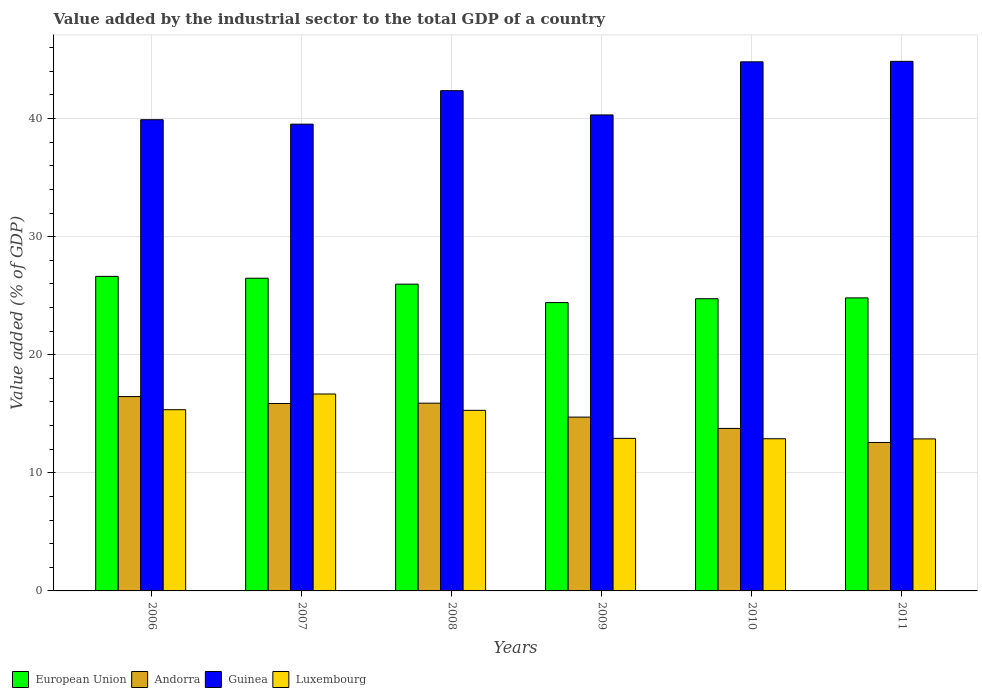How many different coloured bars are there?
Make the answer very short. 4. How many groups of bars are there?
Make the answer very short. 6. How many bars are there on the 2nd tick from the left?
Make the answer very short. 4. What is the label of the 2nd group of bars from the left?
Provide a succinct answer. 2007. What is the value added by the industrial sector to the total GDP in Guinea in 2007?
Offer a terse response. 39.52. Across all years, what is the maximum value added by the industrial sector to the total GDP in Guinea?
Keep it short and to the point. 44.84. Across all years, what is the minimum value added by the industrial sector to the total GDP in Andorra?
Your answer should be very brief. 12.57. In which year was the value added by the industrial sector to the total GDP in European Union maximum?
Offer a very short reply. 2006. What is the total value added by the industrial sector to the total GDP in Guinea in the graph?
Provide a short and direct response. 251.73. What is the difference between the value added by the industrial sector to the total GDP in European Union in 2006 and that in 2011?
Offer a very short reply. 1.82. What is the difference between the value added by the industrial sector to the total GDP in Luxembourg in 2008 and the value added by the industrial sector to the total GDP in European Union in 2010?
Offer a very short reply. -9.45. What is the average value added by the industrial sector to the total GDP in European Union per year?
Your answer should be very brief. 25.51. In the year 2006, what is the difference between the value added by the industrial sector to the total GDP in Luxembourg and value added by the industrial sector to the total GDP in European Union?
Ensure brevity in your answer.  -11.29. In how many years, is the value added by the industrial sector to the total GDP in Andorra greater than 6 %?
Provide a short and direct response. 6. What is the ratio of the value added by the industrial sector to the total GDP in Andorra in 2009 to that in 2010?
Keep it short and to the point. 1.07. What is the difference between the highest and the second highest value added by the industrial sector to the total GDP in Guinea?
Give a very brief answer. 0.04. What is the difference between the highest and the lowest value added by the industrial sector to the total GDP in European Union?
Your answer should be compact. 2.22. Is the sum of the value added by the industrial sector to the total GDP in Guinea in 2006 and 2010 greater than the maximum value added by the industrial sector to the total GDP in European Union across all years?
Keep it short and to the point. Yes. Is it the case that in every year, the sum of the value added by the industrial sector to the total GDP in Luxembourg and value added by the industrial sector to the total GDP in Guinea is greater than the sum of value added by the industrial sector to the total GDP in European Union and value added by the industrial sector to the total GDP in Andorra?
Ensure brevity in your answer.  Yes. What does the 3rd bar from the left in 2008 represents?
Your answer should be compact. Guinea. What does the 4th bar from the right in 2007 represents?
Provide a short and direct response. European Union. How many bars are there?
Offer a very short reply. 24. Are all the bars in the graph horizontal?
Ensure brevity in your answer.  No. How many years are there in the graph?
Give a very brief answer. 6. Does the graph contain any zero values?
Make the answer very short. No. How many legend labels are there?
Your answer should be compact. 4. What is the title of the graph?
Ensure brevity in your answer.  Value added by the industrial sector to the total GDP of a country. Does "San Marino" appear as one of the legend labels in the graph?
Offer a terse response. No. What is the label or title of the X-axis?
Your response must be concise. Years. What is the label or title of the Y-axis?
Give a very brief answer. Value added (% of GDP). What is the Value added (% of GDP) in European Union in 2006?
Give a very brief answer. 26.64. What is the Value added (% of GDP) in Andorra in 2006?
Give a very brief answer. 16.46. What is the Value added (% of GDP) in Guinea in 2006?
Your response must be concise. 39.9. What is the Value added (% of GDP) of Luxembourg in 2006?
Your answer should be compact. 15.34. What is the Value added (% of GDP) of European Union in 2007?
Ensure brevity in your answer.  26.48. What is the Value added (% of GDP) of Andorra in 2007?
Offer a very short reply. 15.87. What is the Value added (% of GDP) of Guinea in 2007?
Your answer should be compact. 39.52. What is the Value added (% of GDP) in Luxembourg in 2007?
Provide a succinct answer. 16.67. What is the Value added (% of GDP) in European Union in 2008?
Give a very brief answer. 25.98. What is the Value added (% of GDP) of Andorra in 2008?
Ensure brevity in your answer.  15.9. What is the Value added (% of GDP) in Guinea in 2008?
Ensure brevity in your answer.  42.36. What is the Value added (% of GDP) in Luxembourg in 2008?
Give a very brief answer. 15.29. What is the Value added (% of GDP) of European Union in 2009?
Ensure brevity in your answer.  24.41. What is the Value added (% of GDP) of Andorra in 2009?
Ensure brevity in your answer.  14.72. What is the Value added (% of GDP) of Guinea in 2009?
Your response must be concise. 40.31. What is the Value added (% of GDP) in Luxembourg in 2009?
Your answer should be compact. 12.92. What is the Value added (% of GDP) of European Union in 2010?
Provide a short and direct response. 24.74. What is the Value added (% of GDP) in Andorra in 2010?
Provide a short and direct response. 13.76. What is the Value added (% of GDP) of Guinea in 2010?
Make the answer very short. 44.8. What is the Value added (% of GDP) of Luxembourg in 2010?
Make the answer very short. 12.89. What is the Value added (% of GDP) in European Union in 2011?
Offer a terse response. 24.81. What is the Value added (% of GDP) of Andorra in 2011?
Provide a succinct answer. 12.57. What is the Value added (% of GDP) of Guinea in 2011?
Give a very brief answer. 44.84. What is the Value added (% of GDP) of Luxembourg in 2011?
Make the answer very short. 12.87. Across all years, what is the maximum Value added (% of GDP) of European Union?
Give a very brief answer. 26.64. Across all years, what is the maximum Value added (% of GDP) of Andorra?
Your answer should be compact. 16.46. Across all years, what is the maximum Value added (% of GDP) in Guinea?
Keep it short and to the point. 44.84. Across all years, what is the maximum Value added (% of GDP) of Luxembourg?
Provide a succinct answer. 16.67. Across all years, what is the minimum Value added (% of GDP) of European Union?
Provide a succinct answer. 24.41. Across all years, what is the minimum Value added (% of GDP) in Andorra?
Offer a very short reply. 12.57. Across all years, what is the minimum Value added (% of GDP) of Guinea?
Your answer should be very brief. 39.52. Across all years, what is the minimum Value added (% of GDP) in Luxembourg?
Make the answer very short. 12.87. What is the total Value added (% of GDP) in European Union in the graph?
Offer a terse response. 153.06. What is the total Value added (% of GDP) of Andorra in the graph?
Ensure brevity in your answer.  89.27. What is the total Value added (% of GDP) in Guinea in the graph?
Offer a terse response. 251.73. What is the total Value added (% of GDP) of Luxembourg in the graph?
Your answer should be compact. 85.99. What is the difference between the Value added (% of GDP) in European Union in 2006 and that in 2007?
Ensure brevity in your answer.  0.16. What is the difference between the Value added (% of GDP) in Andorra in 2006 and that in 2007?
Ensure brevity in your answer.  0.59. What is the difference between the Value added (% of GDP) in Guinea in 2006 and that in 2007?
Provide a short and direct response. 0.38. What is the difference between the Value added (% of GDP) of Luxembourg in 2006 and that in 2007?
Your answer should be compact. -1.33. What is the difference between the Value added (% of GDP) of European Union in 2006 and that in 2008?
Offer a very short reply. 0.66. What is the difference between the Value added (% of GDP) in Andorra in 2006 and that in 2008?
Your answer should be very brief. 0.56. What is the difference between the Value added (% of GDP) of Guinea in 2006 and that in 2008?
Your answer should be compact. -2.46. What is the difference between the Value added (% of GDP) of Luxembourg in 2006 and that in 2008?
Provide a succinct answer. 0.05. What is the difference between the Value added (% of GDP) of European Union in 2006 and that in 2009?
Your response must be concise. 2.22. What is the difference between the Value added (% of GDP) of Andorra in 2006 and that in 2009?
Ensure brevity in your answer.  1.74. What is the difference between the Value added (% of GDP) of Guinea in 2006 and that in 2009?
Keep it short and to the point. -0.41. What is the difference between the Value added (% of GDP) in Luxembourg in 2006 and that in 2009?
Your answer should be very brief. 2.43. What is the difference between the Value added (% of GDP) in European Union in 2006 and that in 2010?
Your answer should be very brief. 1.89. What is the difference between the Value added (% of GDP) in Andorra in 2006 and that in 2010?
Offer a very short reply. 2.7. What is the difference between the Value added (% of GDP) in Guinea in 2006 and that in 2010?
Your response must be concise. -4.9. What is the difference between the Value added (% of GDP) in Luxembourg in 2006 and that in 2010?
Provide a succinct answer. 2.46. What is the difference between the Value added (% of GDP) of European Union in 2006 and that in 2011?
Offer a very short reply. 1.82. What is the difference between the Value added (% of GDP) in Andorra in 2006 and that in 2011?
Make the answer very short. 3.89. What is the difference between the Value added (% of GDP) of Guinea in 2006 and that in 2011?
Ensure brevity in your answer.  -4.94. What is the difference between the Value added (% of GDP) of Luxembourg in 2006 and that in 2011?
Your response must be concise. 2.47. What is the difference between the Value added (% of GDP) of European Union in 2007 and that in 2008?
Offer a very short reply. 0.5. What is the difference between the Value added (% of GDP) of Andorra in 2007 and that in 2008?
Offer a terse response. -0.03. What is the difference between the Value added (% of GDP) of Guinea in 2007 and that in 2008?
Offer a very short reply. -2.84. What is the difference between the Value added (% of GDP) of Luxembourg in 2007 and that in 2008?
Your answer should be compact. 1.38. What is the difference between the Value added (% of GDP) in European Union in 2007 and that in 2009?
Give a very brief answer. 2.06. What is the difference between the Value added (% of GDP) of Andorra in 2007 and that in 2009?
Offer a very short reply. 1.15. What is the difference between the Value added (% of GDP) of Guinea in 2007 and that in 2009?
Provide a succinct answer. -0.78. What is the difference between the Value added (% of GDP) of Luxembourg in 2007 and that in 2009?
Keep it short and to the point. 3.76. What is the difference between the Value added (% of GDP) in European Union in 2007 and that in 2010?
Your answer should be very brief. 1.74. What is the difference between the Value added (% of GDP) in Andorra in 2007 and that in 2010?
Your response must be concise. 2.11. What is the difference between the Value added (% of GDP) in Guinea in 2007 and that in 2010?
Provide a short and direct response. -5.28. What is the difference between the Value added (% of GDP) in Luxembourg in 2007 and that in 2010?
Offer a very short reply. 3.79. What is the difference between the Value added (% of GDP) in European Union in 2007 and that in 2011?
Your response must be concise. 1.67. What is the difference between the Value added (% of GDP) in Andorra in 2007 and that in 2011?
Your answer should be very brief. 3.3. What is the difference between the Value added (% of GDP) in Guinea in 2007 and that in 2011?
Your answer should be very brief. -5.32. What is the difference between the Value added (% of GDP) in Luxembourg in 2007 and that in 2011?
Make the answer very short. 3.8. What is the difference between the Value added (% of GDP) in European Union in 2008 and that in 2009?
Keep it short and to the point. 1.56. What is the difference between the Value added (% of GDP) in Andorra in 2008 and that in 2009?
Keep it short and to the point. 1.18. What is the difference between the Value added (% of GDP) in Guinea in 2008 and that in 2009?
Make the answer very short. 2.05. What is the difference between the Value added (% of GDP) of Luxembourg in 2008 and that in 2009?
Your response must be concise. 2.37. What is the difference between the Value added (% of GDP) in European Union in 2008 and that in 2010?
Your answer should be very brief. 1.23. What is the difference between the Value added (% of GDP) in Andorra in 2008 and that in 2010?
Give a very brief answer. 2.14. What is the difference between the Value added (% of GDP) of Guinea in 2008 and that in 2010?
Your answer should be very brief. -2.44. What is the difference between the Value added (% of GDP) in Luxembourg in 2008 and that in 2010?
Give a very brief answer. 2.41. What is the difference between the Value added (% of GDP) of European Union in 2008 and that in 2011?
Provide a succinct answer. 1.17. What is the difference between the Value added (% of GDP) in Andorra in 2008 and that in 2011?
Give a very brief answer. 3.33. What is the difference between the Value added (% of GDP) in Guinea in 2008 and that in 2011?
Offer a very short reply. -2.48. What is the difference between the Value added (% of GDP) of Luxembourg in 2008 and that in 2011?
Your answer should be compact. 2.42. What is the difference between the Value added (% of GDP) of European Union in 2009 and that in 2010?
Your response must be concise. -0.33. What is the difference between the Value added (% of GDP) of Andorra in 2009 and that in 2010?
Give a very brief answer. 0.96. What is the difference between the Value added (% of GDP) of Guinea in 2009 and that in 2010?
Offer a very short reply. -4.5. What is the difference between the Value added (% of GDP) in Luxembourg in 2009 and that in 2010?
Give a very brief answer. 0.03. What is the difference between the Value added (% of GDP) of European Union in 2009 and that in 2011?
Make the answer very short. -0.4. What is the difference between the Value added (% of GDP) in Andorra in 2009 and that in 2011?
Make the answer very short. 2.15. What is the difference between the Value added (% of GDP) in Guinea in 2009 and that in 2011?
Offer a very short reply. -4.54. What is the difference between the Value added (% of GDP) in Luxembourg in 2009 and that in 2011?
Keep it short and to the point. 0.04. What is the difference between the Value added (% of GDP) in European Union in 2010 and that in 2011?
Your answer should be compact. -0.07. What is the difference between the Value added (% of GDP) of Andorra in 2010 and that in 2011?
Provide a short and direct response. 1.19. What is the difference between the Value added (% of GDP) in Guinea in 2010 and that in 2011?
Provide a short and direct response. -0.04. What is the difference between the Value added (% of GDP) of Luxembourg in 2010 and that in 2011?
Provide a short and direct response. 0.01. What is the difference between the Value added (% of GDP) of European Union in 2006 and the Value added (% of GDP) of Andorra in 2007?
Your response must be concise. 10.76. What is the difference between the Value added (% of GDP) of European Union in 2006 and the Value added (% of GDP) of Guinea in 2007?
Keep it short and to the point. -12.89. What is the difference between the Value added (% of GDP) of European Union in 2006 and the Value added (% of GDP) of Luxembourg in 2007?
Offer a very short reply. 9.96. What is the difference between the Value added (% of GDP) of Andorra in 2006 and the Value added (% of GDP) of Guinea in 2007?
Keep it short and to the point. -23.07. What is the difference between the Value added (% of GDP) of Andorra in 2006 and the Value added (% of GDP) of Luxembourg in 2007?
Make the answer very short. -0.22. What is the difference between the Value added (% of GDP) of Guinea in 2006 and the Value added (% of GDP) of Luxembourg in 2007?
Your answer should be very brief. 23.23. What is the difference between the Value added (% of GDP) in European Union in 2006 and the Value added (% of GDP) in Andorra in 2008?
Ensure brevity in your answer.  10.74. What is the difference between the Value added (% of GDP) of European Union in 2006 and the Value added (% of GDP) of Guinea in 2008?
Offer a very short reply. -15.72. What is the difference between the Value added (% of GDP) in European Union in 2006 and the Value added (% of GDP) in Luxembourg in 2008?
Offer a very short reply. 11.34. What is the difference between the Value added (% of GDP) of Andorra in 2006 and the Value added (% of GDP) of Guinea in 2008?
Provide a succinct answer. -25.9. What is the difference between the Value added (% of GDP) of Andorra in 2006 and the Value added (% of GDP) of Luxembourg in 2008?
Give a very brief answer. 1.17. What is the difference between the Value added (% of GDP) in Guinea in 2006 and the Value added (% of GDP) in Luxembourg in 2008?
Your answer should be very brief. 24.61. What is the difference between the Value added (% of GDP) of European Union in 2006 and the Value added (% of GDP) of Andorra in 2009?
Your answer should be compact. 11.92. What is the difference between the Value added (% of GDP) of European Union in 2006 and the Value added (% of GDP) of Guinea in 2009?
Your answer should be very brief. -13.67. What is the difference between the Value added (% of GDP) of European Union in 2006 and the Value added (% of GDP) of Luxembourg in 2009?
Keep it short and to the point. 13.72. What is the difference between the Value added (% of GDP) in Andorra in 2006 and the Value added (% of GDP) in Guinea in 2009?
Offer a very short reply. -23.85. What is the difference between the Value added (% of GDP) of Andorra in 2006 and the Value added (% of GDP) of Luxembourg in 2009?
Give a very brief answer. 3.54. What is the difference between the Value added (% of GDP) of Guinea in 2006 and the Value added (% of GDP) of Luxembourg in 2009?
Your answer should be very brief. 26.98. What is the difference between the Value added (% of GDP) in European Union in 2006 and the Value added (% of GDP) in Andorra in 2010?
Ensure brevity in your answer.  12.88. What is the difference between the Value added (% of GDP) in European Union in 2006 and the Value added (% of GDP) in Guinea in 2010?
Provide a short and direct response. -18.17. What is the difference between the Value added (% of GDP) in European Union in 2006 and the Value added (% of GDP) in Luxembourg in 2010?
Make the answer very short. 13.75. What is the difference between the Value added (% of GDP) of Andorra in 2006 and the Value added (% of GDP) of Guinea in 2010?
Keep it short and to the point. -28.35. What is the difference between the Value added (% of GDP) in Andorra in 2006 and the Value added (% of GDP) in Luxembourg in 2010?
Offer a very short reply. 3.57. What is the difference between the Value added (% of GDP) in Guinea in 2006 and the Value added (% of GDP) in Luxembourg in 2010?
Your answer should be very brief. 27.01. What is the difference between the Value added (% of GDP) of European Union in 2006 and the Value added (% of GDP) of Andorra in 2011?
Ensure brevity in your answer.  14.07. What is the difference between the Value added (% of GDP) of European Union in 2006 and the Value added (% of GDP) of Guinea in 2011?
Your response must be concise. -18.21. What is the difference between the Value added (% of GDP) in European Union in 2006 and the Value added (% of GDP) in Luxembourg in 2011?
Ensure brevity in your answer.  13.76. What is the difference between the Value added (% of GDP) of Andorra in 2006 and the Value added (% of GDP) of Guinea in 2011?
Your response must be concise. -28.39. What is the difference between the Value added (% of GDP) of Andorra in 2006 and the Value added (% of GDP) of Luxembourg in 2011?
Your response must be concise. 3.58. What is the difference between the Value added (% of GDP) of Guinea in 2006 and the Value added (% of GDP) of Luxembourg in 2011?
Offer a very short reply. 27.03. What is the difference between the Value added (% of GDP) in European Union in 2007 and the Value added (% of GDP) in Andorra in 2008?
Provide a succinct answer. 10.58. What is the difference between the Value added (% of GDP) of European Union in 2007 and the Value added (% of GDP) of Guinea in 2008?
Offer a very short reply. -15.88. What is the difference between the Value added (% of GDP) in European Union in 2007 and the Value added (% of GDP) in Luxembourg in 2008?
Offer a terse response. 11.19. What is the difference between the Value added (% of GDP) in Andorra in 2007 and the Value added (% of GDP) in Guinea in 2008?
Your answer should be very brief. -26.49. What is the difference between the Value added (% of GDP) in Andorra in 2007 and the Value added (% of GDP) in Luxembourg in 2008?
Your response must be concise. 0.58. What is the difference between the Value added (% of GDP) in Guinea in 2007 and the Value added (% of GDP) in Luxembourg in 2008?
Give a very brief answer. 24.23. What is the difference between the Value added (% of GDP) of European Union in 2007 and the Value added (% of GDP) of Andorra in 2009?
Your response must be concise. 11.76. What is the difference between the Value added (% of GDP) of European Union in 2007 and the Value added (% of GDP) of Guinea in 2009?
Keep it short and to the point. -13.83. What is the difference between the Value added (% of GDP) of European Union in 2007 and the Value added (% of GDP) of Luxembourg in 2009?
Make the answer very short. 13.56. What is the difference between the Value added (% of GDP) of Andorra in 2007 and the Value added (% of GDP) of Guinea in 2009?
Offer a terse response. -24.43. What is the difference between the Value added (% of GDP) in Andorra in 2007 and the Value added (% of GDP) in Luxembourg in 2009?
Offer a terse response. 2.95. What is the difference between the Value added (% of GDP) of Guinea in 2007 and the Value added (% of GDP) of Luxembourg in 2009?
Provide a succinct answer. 26.61. What is the difference between the Value added (% of GDP) in European Union in 2007 and the Value added (% of GDP) in Andorra in 2010?
Offer a very short reply. 12.72. What is the difference between the Value added (% of GDP) in European Union in 2007 and the Value added (% of GDP) in Guinea in 2010?
Your response must be concise. -18.32. What is the difference between the Value added (% of GDP) in European Union in 2007 and the Value added (% of GDP) in Luxembourg in 2010?
Provide a short and direct response. 13.59. What is the difference between the Value added (% of GDP) of Andorra in 2007 and the Value added (% of GDP) of Guinea in 2010?
Provide a succinct answer. -28.93. What is the difference between the Value added (% of GDP) of Andorra in 2007 and the Value added (% of GDP) of Luxembourg in 2010?
Offer a very short reply. 2.99. What is the difference between the Value added (% of GDP) of Guinea in 2007 and the Value added (% of GDP) of Luxembourg in 2010?
Keep it short and to the point. 26.64. What is the difference between the Value added (% of GDP) in European Union in 2007 and the Value added (% of GDP) in Andorra in 2011?
Make the answer very short. 13.91. What is the difference between the Value added (% of GDP) in European Union in 2007 and the Value added (% of GDP) in Guinea in 2011?
Make the answer very short. -18.36. What is the difference between the Value added (% of GDP) in European Union in 2007 and the Value added (% of GDP) in Luxembourg in 2011?
Your answer should be compact. 13.61. What is the difference between the Value added (% of GDP) of Andorra in 2007 and the Value added (% of GDP) of Guinea in 2011?
Your answer should be compact. -28.97. What is the difference between the Value added (% of GDP) of Andorra in 2007 and the Value added (% of GDP) of Luxembourg in 2011?
Offer a very short reply. 3. What is the difference between the Value added (% of GDP) of Guinea in 2007 and the Value added (% of GDP) of Luxembourg in 2011?
Make the answer very short. 26.65. What is the difference between the Value added (% of GDP) of European Union in 2008 and the Value added (% of GDP) of Andorra in 2009?
Offer a terse response. 11.26. What is the difference between the Value added (% of GDP) in European Union in 2008 and the Value added (% of GDP) in Guinea in 2009?
Provide a short and direct response. -14.33. What is the difference between the Value added (% of GDP) of European Union in 2008 and the Value added (% of GDP) of Luxembourg in 2009?
Your response must be concise. 13.06. What is the difference between the Value added (% of GDP) in Andorra in 2008 and the Value added (% of GDP) in Guinea in 2009?
Keep it short and to the point. -24.41. What is the difference between the Value added (% of GDP) in Andorra in 2008 and the Value added (% of GDP) in Luxembourg in 2009?
Your answer should be very brief. 2.98. What is the difference between the Value added (% of GDP) in Guinea in 2008 and the Value added (% of GDP) in Luxembourg in 2009?
Ensure brevity in your answer.  29.44. What is the difference between the Value added (% of GDP) of European Union in 2008 and the Value added (% of GDP) of Andorra in 2010?
Offer a very short reply. 12.22. What is the difference between the Value added (% of GDP) of European Union in 2008 and the Value added (% of GDP) of Guinea in 2010?
Provide a short and direct response. -18.83. What is the difference between the Value added (% of GDP) in European Union in 2008 and the Value added (% of GDP) in Luxembourg in 2010?
Your answer should be compact. 13.09. What is the difference between the Value added (% of GDP) of Andorra in 2008 and the Value added (% of GDP) of Guinea in 2010?
Provide a short and direct response. -28.91. What is the difference between the Value added (% of GDP) in Andorra in 2008 and the Value added (% of GDP) in Luxembourg in 2010?
Your answer should be very brief. 3.01. What is the difference between the Value added (% of GDP) of Guinea in 2008 and the Value added (% of GDP) of Luxembourg in 2010?
Your answer should be compact. 29.47. What is the difference between the Value added (% of GDP) in European Union in 2008 and the Value added (% of GDP) in Andorra in 2011?
Offer a terse response. 13.41. What is the difference between the Value added (% of GDP) of European Union in 2008 and the Value added (% of GDP) of Guinea in 2011?
Give a very brief answer. -18.86. What is the difference between the Value added (% of GDP) of European Union in 2008 and the Value added (% of GDP) of Luxembourg in 2011?
Keep it short and to the point. 13.1. What is the difference between the Value added (% of GDP) in Andorra in 2008 and the Value added (% of GDP) in Guinea in 2011?
Your answer should be compact. -28.94. What is the difference between the Value added (% of GDP) in Andorra in 2008 and the Value added (% of GDP) in Luxembourg in 2011?
Offer a very short reply. 3.03. What is the difference between the Value added (% of GDP) of Guinea in 2008 and the Value added (% of GDP) of Luxembourg in 2011?
Offer a very short reply. 29.49. What is the difference between the Value added (% of GDP) in European Union in 2009 and the Value added (% of GDP) in Andorra in 2010?
Provide a short and direct response. 10.65. What is the difference between the Value added (% of GDP) of European Union in 2009 and the Value added (% of GDP) of Guinea in 2010?
Make the answer very short. -20.39. What is the difference between the Value added (% of GDP) of European Union in 2009 and the Value added (% of GDP) of Luxembourg in 2010?
Offer a terse response. 11.53. What is the difference between the Value added (% of GDP) of Andorra in 2009 and the Value added (% of GDP) of Guinea in 2010?
Provide a short and direct response. -30.08. What is the difference between the Value added (% of GDP) in Andorra in 2009 and the Value added (% of GDP) in Luxembourg in 2010?
Provide a short and direct response. 1.83. What is the difference between the Value added (% of GDP) of Guinea in 2009 and the Value added (% of GDP) of Luxembourg in 2010?
Provide a short and direct response. 27.42. What is the difference between the Value added (% of GDP) of European Union in 2009 and the Value added (% of GDP) of Andorra in 2011?
Keep it short and to the point. 11.85. What is the difference between the Value added (% of GDP) in European Union in 2009 and the Value added (% of GDP) in Guinea in 2011?
Make the answer very short. -20.43. What is the difference between the Value added (% of GDP) in European Union in 2009 and the Value added (% of GDP) in Luxembourg in 2011?
Provide a succinct answer. 11.54. What is the difference between the Value added (% of GDP) in Andorra in 2009 and the Value added (% of GDP) in Guinea in 2011?
Offer a very short reply. -30.12. What is the difference between the Value added (% of GDP) in Andorra in 2009 and the Value added (% of GDP) in Luxembourg in 2011?
Provide a short and direct response. 1.85. What is the difference between the Value added (% of GDP) in Guinea in 2009 and the Value added (% of GDP) in Luxembourg in 2011?
Your answer should be very brief. 27.43. What is the difference between the Value added (% of GDP) in European Union in 2010 and the Value added (% of GDP) in Andorra in 2011?
Offer a very short reply. 12.17. What is the difference between the Value added (% of GDP) in European Union in 2010 and the Value added (% of GDP) in Guinea in 2011?
Keep it short and to the point. -20.1. What is the difference between the Value added (% of GDP) of European Union in 2010 and the Value added (% of GDP) of Luxembourg in 2011?
Your answer should be very brief. 11.87. What is the difference between the Value added (% of GDP) of Andorra in 2010 and the Value added (% of GDP) of Guinea in 2011?
Offer a terse response. -31.08. What is the difference between the Value added (% of GDP) in Andorra in 2010 and the Value added (% of GDP) in Luxembourg in 2011?
Offer a terse response. 0.89. What is the difference between the Value added (% of GDP) of Guinea in 2010 and the Value added (% of GDP) of Luxembourg in 2011?
Give a very brief answer. 31.93. What is the average Value added (% of GDP) of European Union per year?
Your answer should be very brief. 25.51. What is the average Value added (% of GDP) of Andorra per year?
Make the answer very short. 14.88. What is the average Value added (% of GDP) in Guinea per year?
Your answer should be compact. 41.96. What is the average Value added (% of GDP) in Luxembourg per year?
Provide a succinct answer. 14.33. In the year 2006, what is the difference between the Value added (% of GDP) of European Union and Value added (% of GDP) of Andorra?
Offer a terse response. 10.18. In the year 2006, what is the difference between the Value added (% of GDP) in European Union and Value added (% of GDP) in Guinea?
Your answer should be very brief. -13.26. In the year 2006, what is the difference between the Value added (% of GDP) in European Union and Value added (% of GDP) in Luxembourg?
Offer a very short reply. 11.29. In the year 2006, what is the difference between the Value added (% of GDP) in Andorra and Value added (% of GDP) in Guinea?
Keep it short and to the point. -23.44. In the year 2006, what is the difference between the Value added (% of GDP) of Andorra and Value added (% of GDP) of Luxembourg?
Offer a terse response. 1.11. In the year 2006, what is the difference between the Value added (% of GDP) in Guinea and Value added (% of GDP) in Luxembourg?
Make the answer very short. 24.56. In the year 2007, what is the difference between the Value added (% of GDP) in European Union and Value added (% of GDP) in Andorra?
Your answer should be very brief. 10.61. In the year 2007, what is the difference between the Value added (% of GDP) of European Union and Value added (% of GDP) of Guinea?
Your response must be concise. -13.04. In the year 2007, what is the difference between the Value added (% of GDP) in European Union and Value added (% of GDP) in Luxembourg?
Give a very brief answer. 9.81. In the year 2007, what is the difference between the Value added (% of GDP) of Andorra and Value added (% of GDP) of Guinea?
Your answer should be very brief. -23.65. In the year 2007, what is the difference between the Value added (% of GDP) of Andorra and Value added (% of GDP) of Luxembourg?
Give a very brief answer. -0.8. In the year 2007, what is the difference between the Value added (% of GDP) of Guinea and Value added (% of GDP) of Luxembourg?
Your answer should be compact. 22.85. In the year 2008, what is the difference between the Value added (% of GDP) of European Union and Value added (% of GDP) of Andorra?
Provide a succinct answer. 10.08. In the year 2008, what is the difference between the Value added (% of GDP) in European Union and Value added (% of GDP) in Guinea?
Your response must be concise. -16.38. In the year 2008, what is the difference between the Value added (% of GDP) in European Union and Value added (% of GDP) in Luxembourg?
Offer a very short reply. 10.69. In the year 2008, what is the difference between the Value added (% of GDP) of Andorra and Value added (% of GDP) of Guinea?
Your response must be concise. -26.46. In the year 2008, what is the difference between the Value added (% of GDP) of Andorra and Value added (% of GDP) of Luxembourg?
Provide a succinct answer. 0.61. In the year 2008, what is the difference between the Value added (% of GDP) of Guinea and Value added (% of GDP) of Luxembourg?
Offer a very short reply. 27.07. In the year 2009, what is the difference between the Value added (% of GDP) in European Union and Value added (% of GDP) in Andorra?
Ensure brevity in your answer.  9.7. In the year 2009, what is the difference between the Value added (% of GDP) in European Union and Value added (% of GDP) in Guinea?
Ensure brevity in your answer.  -15.89. In the year 2009, what is the difference between the Value added (% of GDP) of European Union and Value added (% of GDP) of Luxembourg?
Ensure brevity in your answer.  11.5. In the year 2009, what is the difference between the Value added (% of GDP) of Andorra and Value added (% of GDP) of Guinea?
Ensure brevity in your answer.  -25.59. In the year 2009, what is the difference between the Value added (% of GDP) of Andorra and Value added (% of GDP) of Luxembourg?
Offer a very short reply. 1.8. In the year 2009, what is the difference between the Value added (% of GDP) of Guinea and Value added (% of GDP) of Luxembourg?
Your response must be concise. 27.39. In the year 2010, what is the difference between the Value added (% of GDP) of European Union and Value added (% of GDP) of Andorra?
Your response must be concise. 10.98. In the year 2010, what is the difference between the Value added (% of GDP) in European Union and Value added (% of GDP) in Guinea?
Ensure brevity in your answer.  -20.06. In the year 2010, what is the difference between the Value added (% of GDP) of European Union and Value added (% of GDP) of Luxembourg?
Provide a short and direct response. 11.86. In the year 2010, what is the difference between the Value added (% of GDP) in Andorra and Value added (% of GDP) in Guinea?
Give a very brief answer. -31.04. In the year 2010, what is the difference between the Value added (% of GDP) of Andorra and Value added (% of GDP) of Luxembourg?
Your response must be concise. 0.87. In the year 2010, what is the difference between the Value added (% of GDP) of Guinea and Value added (% of GDP) of Luxembourg?
Your answer should be compact. 31.92. In the year 2011, what is the difference between the Value added (% of GDP) of European Union and Value added (% of GDP) of Andorra?
Your response must be concise. 12.24. In the year 2011, what is the difference between the Value added (% of GDP) of European Union and Value added (% of GDP) of Guinea?
Provide a succinct answer. -20.03. In the year 2011, what is the difference between the Value added (% of GDP) in European Union and Value added (% of GDP) in Luxembourg?
Your answer should be compact. 11.94. In the year 2011, what is the difference between the Value added (% of GDP) of Andorra and Value added (% of GDP) of Guinea?
Offer a terse response. -32.27. In the year 2011, what is the difference between the Value added (% of GDP) of Andorra and Value added (% of GDP) of Luxembourg?
Your answer should be very brief. -0.3. In the year 2011, what is the difference between the Value added (% of GDP) in Guinea and Value added (% of GDP) in Luxembourg?
Offer a very short reply. 31.97. What is the ratio of the Value added (% of GDP) of European Union in 2006 to that in 2007?
Offer a very short reply. 1.01. What is the ratio of the Value added (% of GDP) of Andorra in 2006 to that in 2007?
Your answer should be very brief. 1.04. What is the ratio of the Value added (% of GDP) of Guinea in 2006 to that in 2007?
Keep it short and to the point. 1.01. What is the ratio of the Value added (% of GDP) of Luxembourg in 2006 to that in 2007?
Make the answer very short. 0.92. What is the ratio of the Value added (% of GDP) in European Union in 2006 to that in 2008?
Offer a very short reply. 1.03. What is the ratio of the Value added (% of GDP) in Andorra in 2006 to that in 2008?
Provide a short and direct response. 1.04. What is the ratio of the Value added (% of GDP) of Guinea in 2006 to that in 2008?
Give a very brief answer. 0.94. What is the ratio of the Value added (% of GDP) of Luxembourg in 2006 to that in 2008?
Give a very brief answer. 1. What is the ratio of the Value added (% of GDP) of European Union in 2006 to that in 2009?
Keep it short and to the point. 1.09. What is the ratio of the Value added (% of GDP) in Andorra in 2006 to that in 2009?
Offer a very short reply. 1.12. What is the ratio of the Value added (% of GDP) in Guinea in 2006 to that in 2009?
Offer a terse response. 0.99. What is the ratio of the Value added (% of GDP) in Luxembourg in 2006 to that in 2009?
Keep it short and to the point. 1.19. What is the ratio of the Value added (% of GDP) of European Union in 2006 to that in 2010?
Ensure brevity in your answer.  1.08. What is the ratio of the Value added (% of GDP) of Andorra in 2006 to that in 2010?
Your response must be concise. 1.2. What is the ratio of the Value added (% of GDP) of Guinea in 2006 to that in 2010?
Make the answer very short. 0.89. What is the ratio of the Value added (% of GDP) of Luxembourg in 2006 to that in 2010?
Provide a short and direct response. 1.19. What is the ratio of the Value added (% of GDP) of European Union in 2006 to that in 2011?
Make the answer very short. 1.07. What is the ratio of the Value added (% of GDP) of Andorra in 2006 to that in 2011?
Provide a short and direct response. 1.31. What is the ratio of the Value added (% of GDP) of Guinea in 2006 to that in 2011?
Your answer should be very brief. 0.89. What is the ratio of the Value added (% of GDP) of Luxembourg in 2006 to that in 2011?
Your response must be concise. 1.19. What is the ratio of the Value added (% of GDP) in European Union in 2007 to that in 2008?
Your response must be concise. 1.02. What is the ratio of the Value added (% of GDP) in Andorra in 2007 to that in 2008?
Your answer should be compact. 1. What is the ratio of the Value added (% of GDP) of Guinea in 2007 to that in 2008?
Your answer should be very brief. 0.93. What is the ratio of the Value added (% of GDP) of Luxembourg in 2007 to that in 2008?
Your response must be concise. 1.09. What is the ratio of the Value added (% of GDP) of European Union in 2007 to that in 2009?
Offer a very short reply. 1.08. What is the ratio of the Value added (% of GDP) of Andorra in 2007 to that in 2009?
Your answer should be compact. 1.08. What is the ratio of the Value added (% of GDP) of Guinea in 2007 to that in 2009?
Offer a terse response. 0.98. What is the ratio of the Value added (% of GDP) in Luxembourg in 2007 to that in 2009?
Offer a very short reply. 1.29. What is the ratio of the Value added (% of GDP) in European Union in 2007 to that in 2010?
Ensure brevity in your answer.  1.07. What is the ratio of the Value added (% of GDP) of Andorra in 2007 to that in 2010?
Offer a very short reply. 1.15. What is the ratio of the Value added (% of GDP) in Guinea in 2007 to that in 2010?
Your response must be concise. 0.88. What is the ratio of the Value added (% of GDP) of Luxembourg in 2007 to that in 2010?
Offer a very short reply. 1.29. What is the ratio of the Value added (% of GDP) in European Union in 2007 to that in 2011?
Provide a short and direct response. 1.07. What is the ratio of the Value added (% of GDP) of Andorra in 2007 to that in 2011?
Your answer should be compact. 1.26. What is the ratio of the Value added (% of GDP) in Guinea in 2007 to that in 2011?
Offer a very short reply. 0.88. What is the ratio of the Value added (% of GDP) in Luxembourg in 2007 to that in 2011?
Provide a succinct answer. 1.3. What is the ratio of the Value added (% of GDP) of European Union in 2008 to that in 2009?
Offer a very short reply. 1.06. What is the ratio of the Value added (% of GDP) in Andorra in 2008 to that in 2009?
Your answer should be very brief. 1.08. What is the ratio of the Value added (% of GDP) in Guinea in 2008 to that in 2009?
Ensure brevity in your answer.  1.05. What is the ratio of the Value added (% of GDP) in Luxembourg in 2008 to that in 2009?
Ensure brevity in your answer.  1.18. What is the ratio of the Value added (% of GDP) in European Union in 2008 to that in 2010?
Provide a succinct answer. 1.05. What is the ratio of the Value added (% of GDP) in Andorra in 2008 to that in 2010?
Offer a terse response. 1.16. What is the ratio of the Value added (% of GDP) of Guinea in 2008 to that in 2010?
Offer a very short reply. 0.95. What is the ratio of the Value added (% of GDP) of Luxembourg in 2008 to that in 2010?
Provide a short and direct response. 1.19. What is the ratio of the Value added (% of GDP) of European Union in 2008 to that in 2011?
Your answer should be compact. 1.05. What is the ratio of the Value added (% of GDP) in Andorra in 2008 to that in 2011?
Offer a very short reply. 1.26. What is the ratio of the Value added (% of GDP) in Guinea in 2008 to that in 2011?
Keep it short and to the point. 0.94. What is the ratio of the Value added (% of GDP) of Luxembourg in 2008 to that in 2011?
Provide a succinct answer. 1.19. What is the ratio of the Value added (% of GDP) of European Union in 2009 to that in 2010?
Your answer should be very brief. 0.99. What is the ratio of the Value added (% of GDP) of Andorra in 2009 to that in 2010?
Ensure brevity in your answer.  1.07. What is the ratio of the Value added (% of GDP) of Guinea in 2009 to that in 2010?
Your answer should be compact. 0.9. What is the ratio of the Value added (% of GDP) of European Union in 2009 to that in 2011?
Offer a very short reply. 0.98. What is the ratio of the Value added (% of GDP) of Andorra in 2009 to that in 2011?
Make the answer very short. 1.17. What is the ratio of the Value added (% of GDP) of Guinea in 2009 to that in 2011?
Ensure brevity in your answer.  0.9. What is the ratio of the Value added (% of GDP) of European Union in 2010 to that in 2011?
Your answer should be compact. 1. What is the ratio of the Value added (% of GDP) in Andorra in 2010 to that in 2011?
Your response must be concise. 1.09. What is the difference between the highest and the second highest Value added (% of GDP) in European Union?
Offer a very short reply. 0.16. What is the difference between the highest and the second highest Value added (% of GDP) in Andorra?
Provide a succinct answer. 0.56. What is the difference between the highest and the second highest Value added (% of GDP) in Guinea?
Your answer should be compact. 0.04. What is the difference between the highest and the second highest Value added (% of GDP) in Luxembourg?
Your answer should be compact. 1.33. What is the difference between the highest and the lowest Value added (% of GDP) in European Union?
Make the answer very short. 2.22. What is the difference between the highest and the lowest Value added (% of GDP) in Andorra?
Offer a very short reply. 3.89. What is the difference between the highest and the lowest Value added (% of GDP) in Guinea?
Make the answer very short. 5.32. What is the difference between the highest and the lowest Value added (% of GDP) in Luxembourg?
Your answer should be very brief. 3.8. 